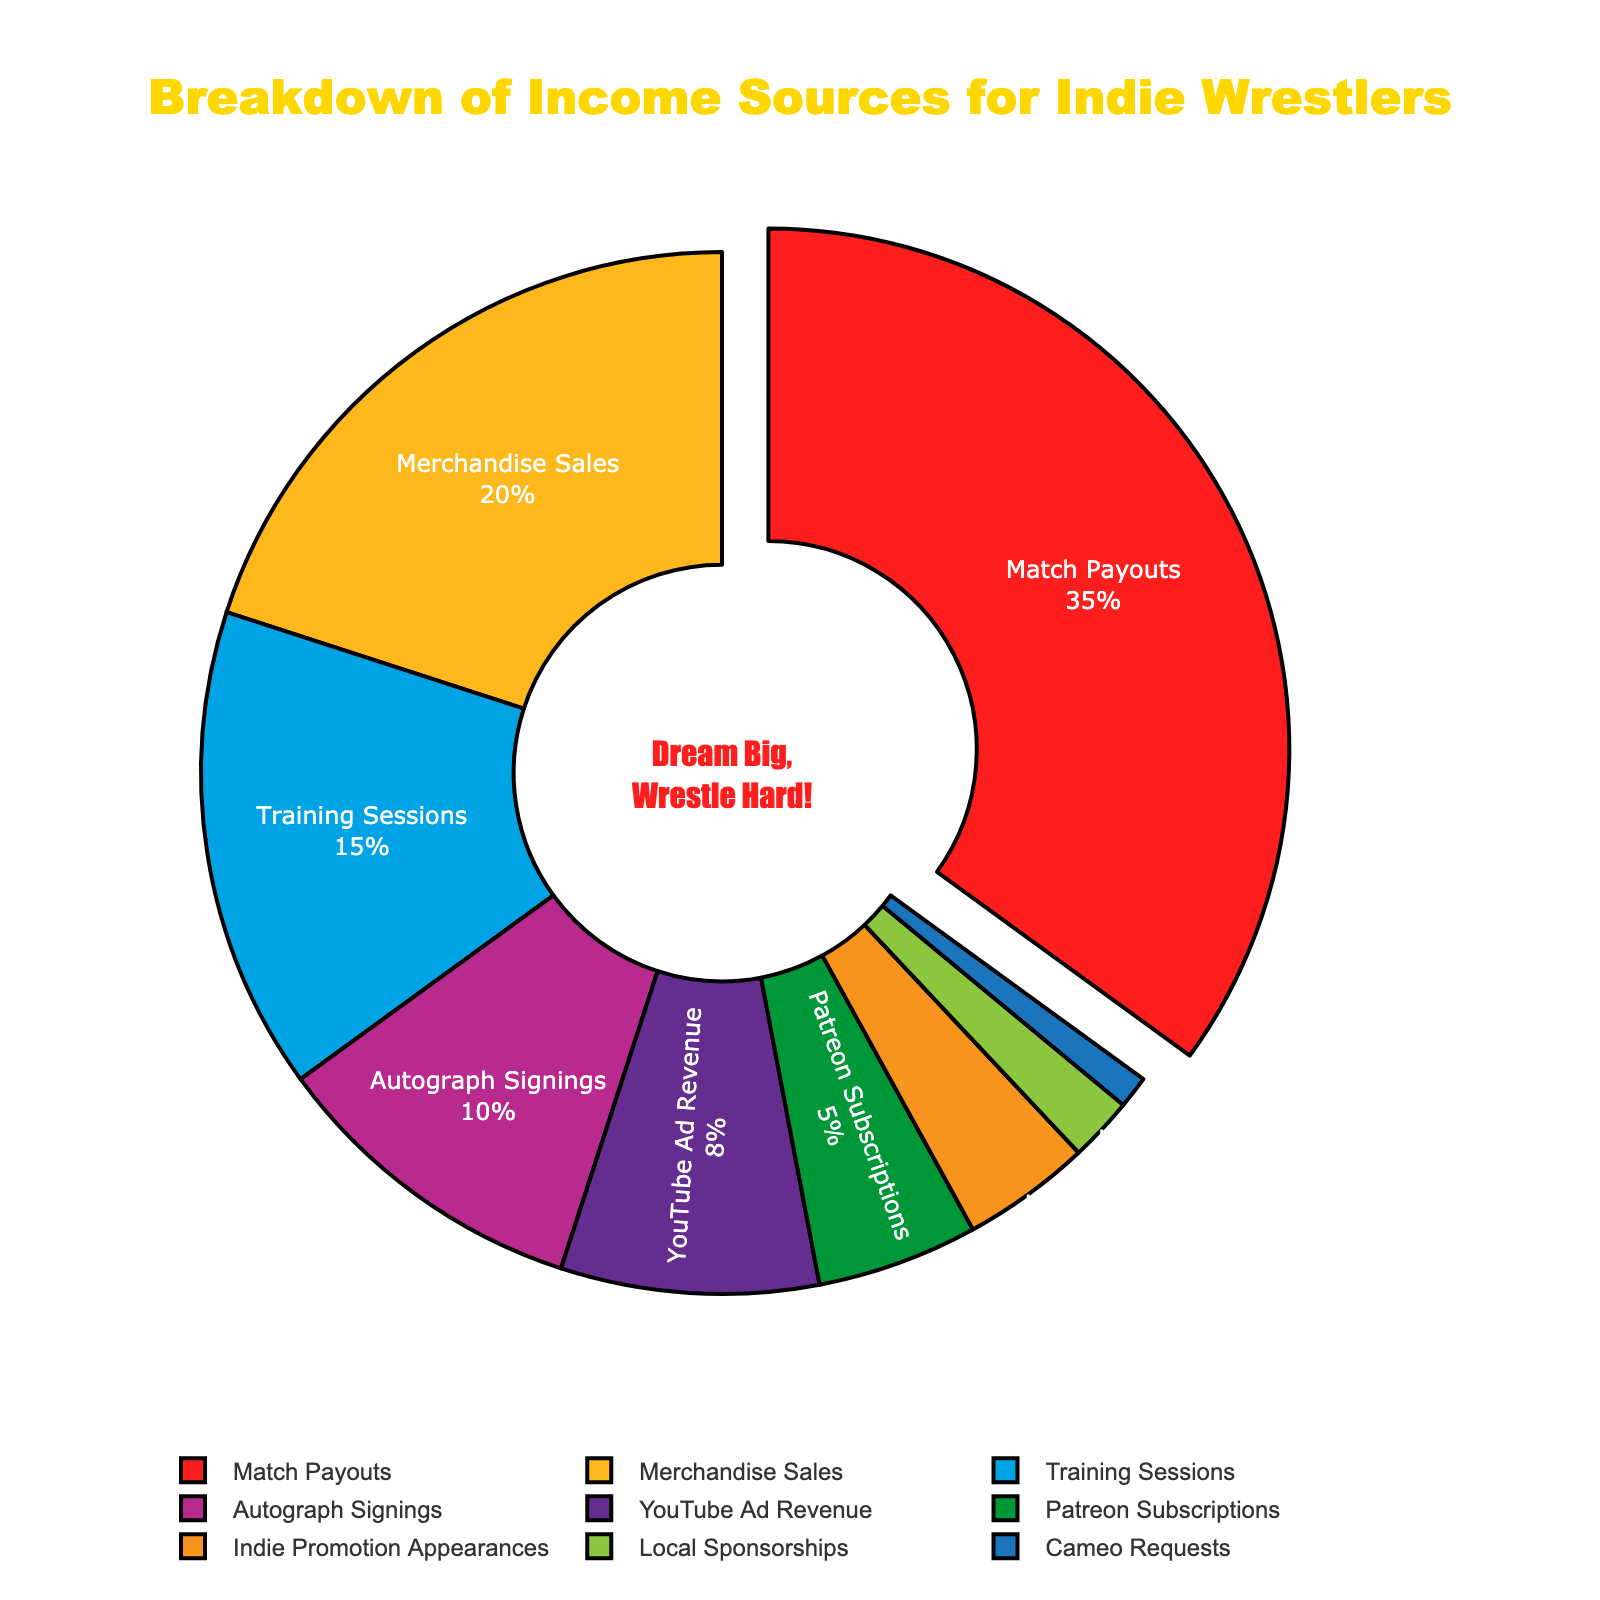What is the largest single source of income for indie wrestlers according to the chart? Match Payouts occupies the largest slice of the pie chart, labeled as 35%.
Answer: Match Payouts Which income source contributes more to the total income of indie wrestlers: YouTube Ad Revenue or Patreon Subscriptions? YouTube Ad Revenue contributes 8%, whereas Patreon Subscriptions contribute 5%, so YouTube Ad Revenue is greater.
Answer: YouTube Ad Revenue What is the combined percentage of Match Payouts and Merchandise Sales? Match Payouts is 35% and Merchandise Sales is 20%. Adding them together gives 35% + 20% = 55%.
Answer: 55% How does the percentage of Autograph Signings compare to Training Sessions? Autograph Signings accounts for 10% and Training Sessions for 15%. Therefore, Training Sessions is 5% higher than Autograph Signings.
Answer: Training Sessions is higher by 5% What percentage of the income sources are less than 5% individually? Indie Promotion Appearances (4%), Local Sponsorships (2%), and Cameo Requests (1%) each contribute less than 5%. Adding these percentages gives 4% + 2% + 1% = 7%.
Answer: 7% Which source between Local Sponsorships and Cameo Requests contributes less, and by how much? Local Sponsorships contribute 2% and Cameo Requests contribute 1%. The difference is 2% - 1% = 1%.
Answer: Cameo Requests by 1% If Match Payouts and Merchandise Sales were combined into a single income source, what would its percentage be and how much greater is it compared to the next largest income source? Combining Match Payouts (35%) and Merchandise Sales (20%) gives 55%. The next largest income source is Training Sessions at 15%, making the combined source 55% - 15% = 40% greater.
Answer: 55%, 40% greater Rank the income sources in descending order based on their percentage contributions. The order from highest to lowest is: Match Payouts (35%), Merchandise Sales (20%), Training Sessions (15%), Autograph Signings (10%), YouTube Ad Revenue (8%), Patreon Subscriptions (5%), Indie Promotion Appearances (4%), Local Sponsorships (2%), Cameo Requests (1%).
Answer: Match Payouts, Merchandise Sales, Training Sessions, Autograph Signings, YouTube Ad Revenue, Patreon Subscriptions, Indie Promotion Appearances, Local Sponsorships, Cameo Requests What visual feature is used to highlight the primary income source, and what percentage does this source represent? The primary income source, Match Payouts, is visually highlighted by being slightly pulled out from the main pie and it represents 35%.
Answer: Pulled out slice, 35% 